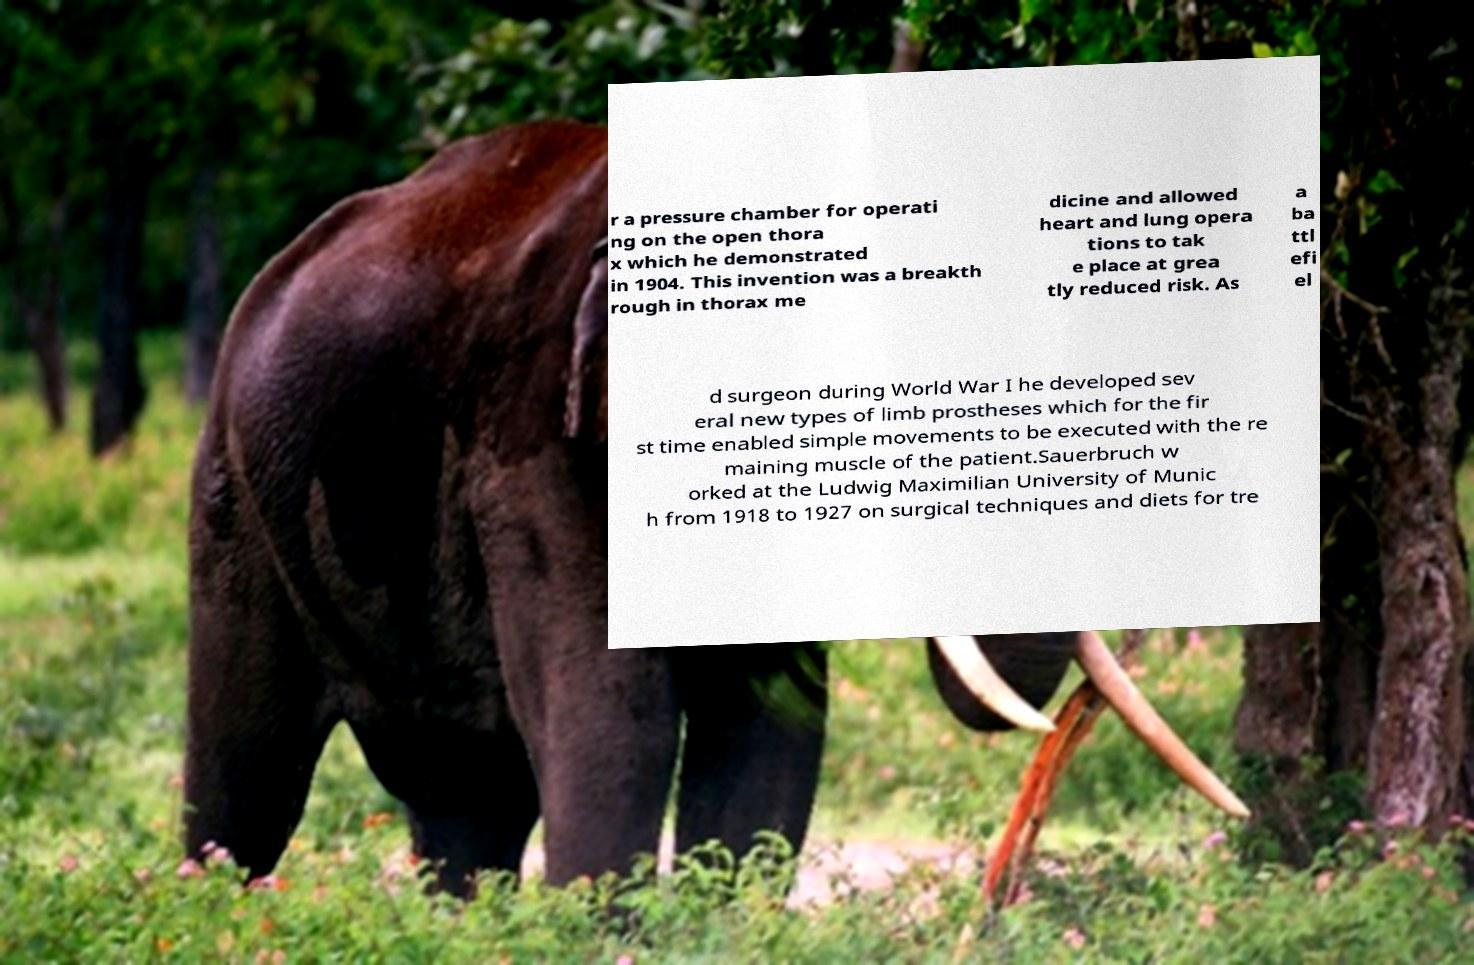Can you accurately transcribe the text from the provided image for me? r a pressure chamber for operati ng on the open thora x which he demonstrated in 1904. This invention was a breakth rough in thorax me dicine and allowed heart and lung opera tions to tak e place at grea tly reduced risk. As a ba ttl efi el d surgeon during World War I he developed sev eral new types of limb prostheses which for the fir st time enabled simple movements to be executed with the re maining muscle of the patient.Sauerbruch w orked at the Ludwig Maximilian University of Munic h from 1918 to 1927 on surgical techniques and diets for tre 